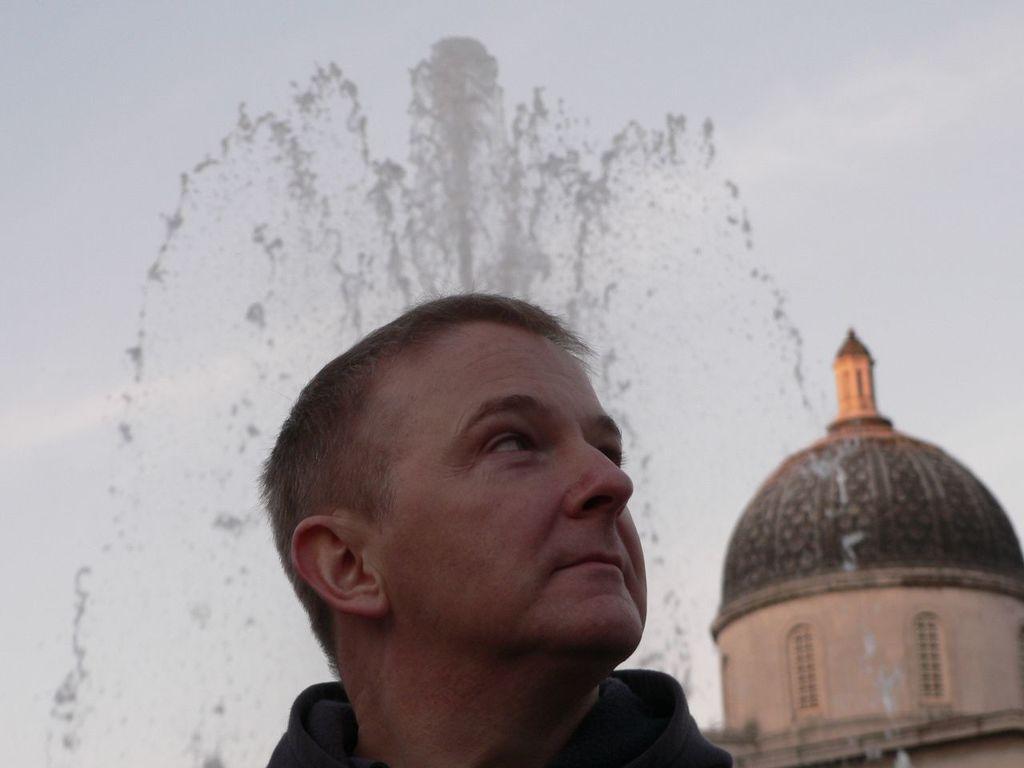How would you summarize this image in a sentence or two? In this image, we can see a person. We can also see a building with its tomb. In the background, we can see the fountain and the sky. 